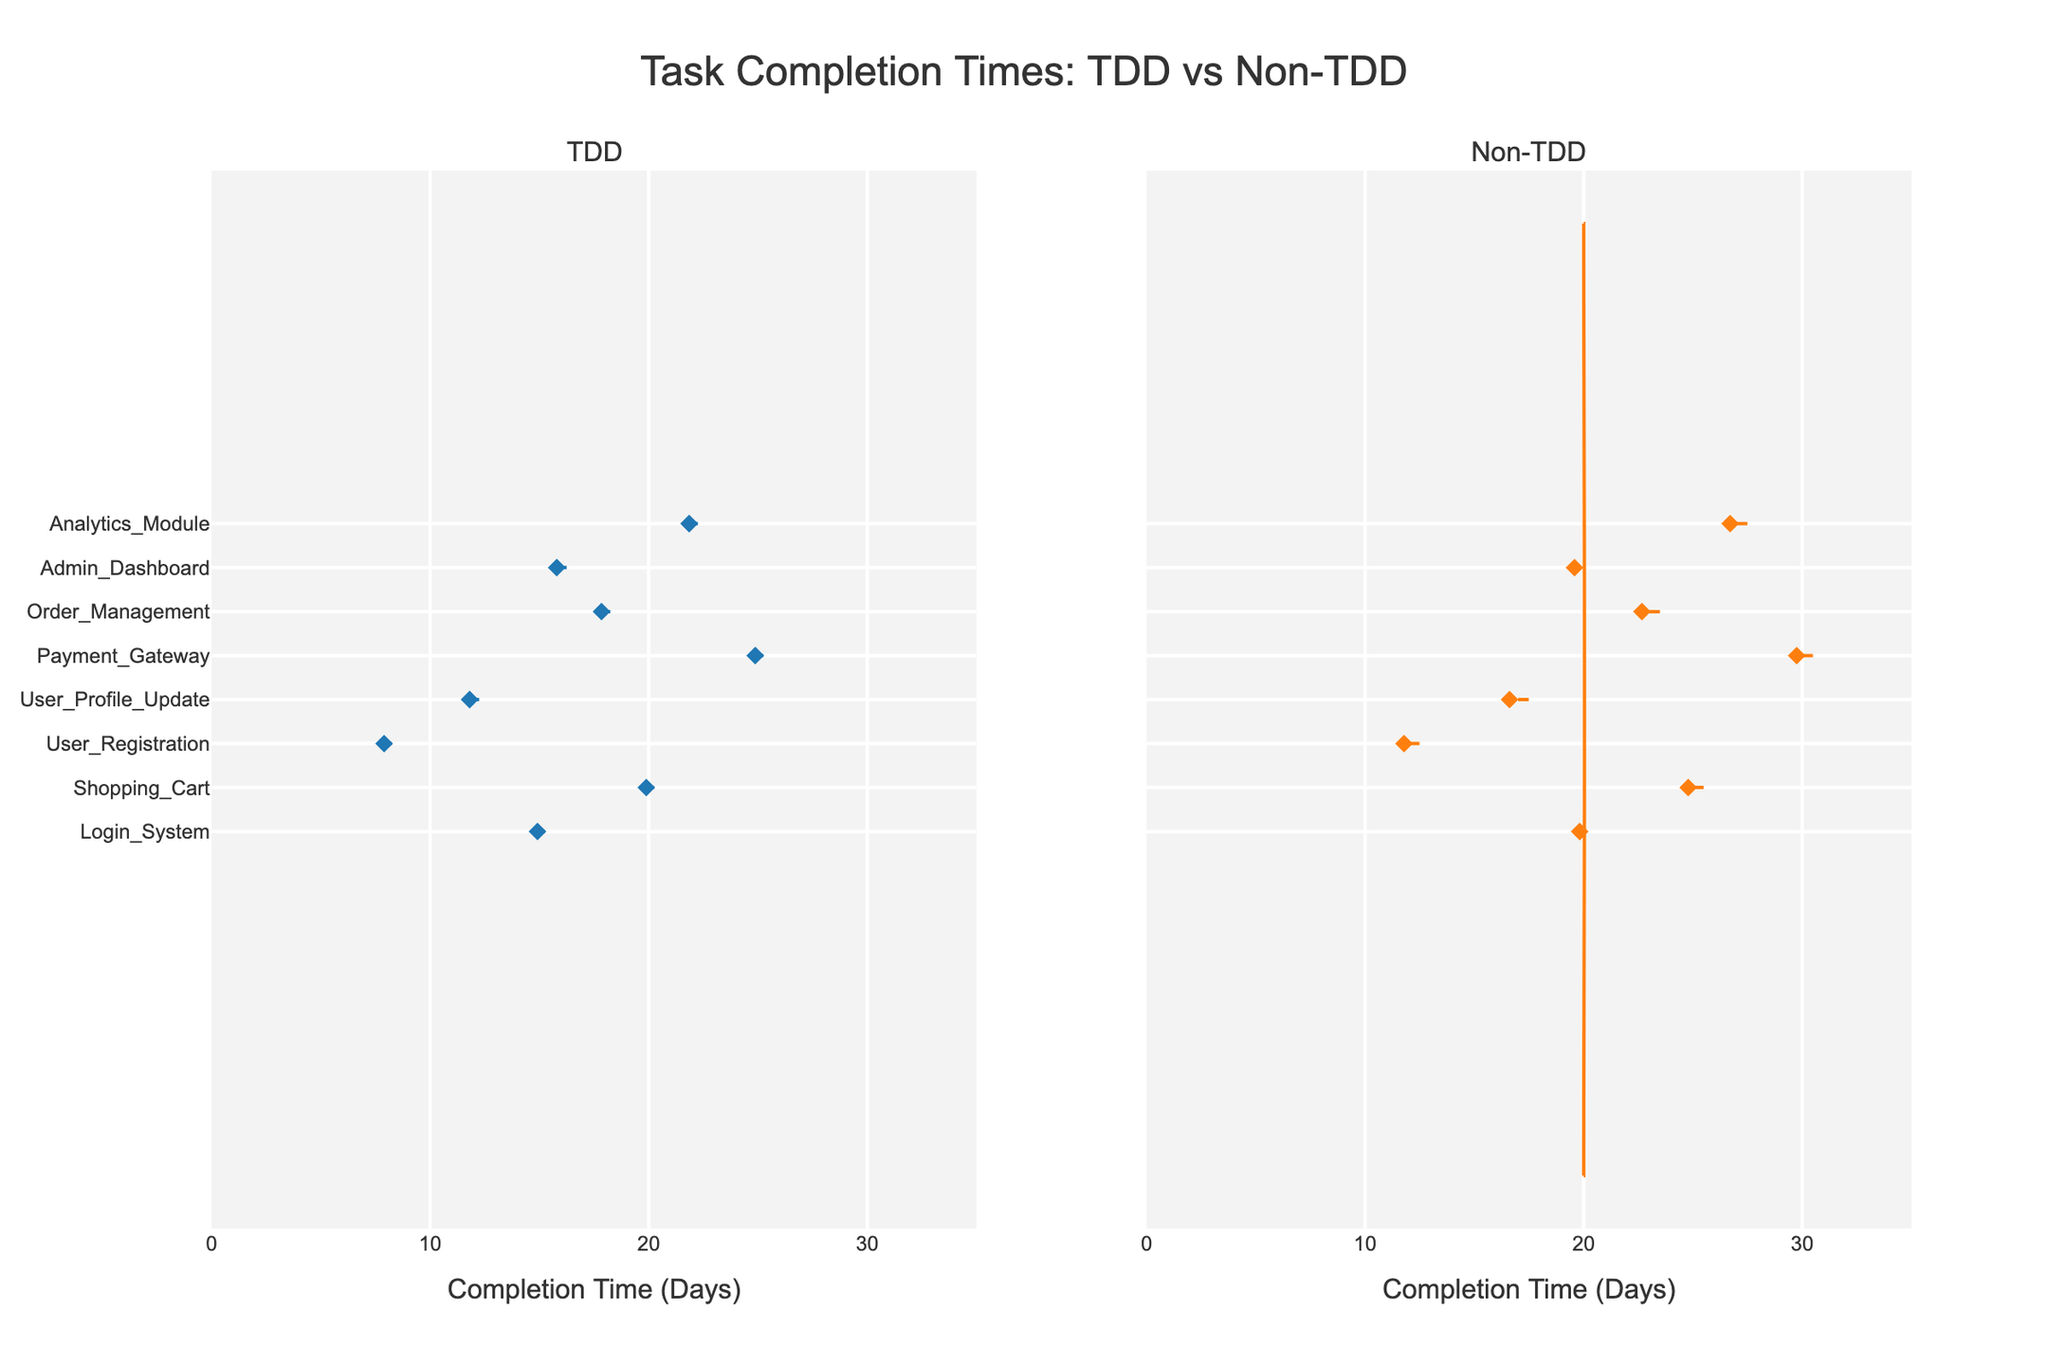What's the title of the plot? The title of the plot is centrally aligned at the top and is displayed in a larger font size. It reads "Task Completion Times: TDD vs Non-TDD".
Answer: Task Completion Times: TDD vs Non-TDD Which task has the shortest completion time under TDD? The shortest completion time under TDD can be found by identifying the lowest point on the TDD side of the plot, which corresponds to the User_Registration task with a completion time of 8 days.
Answer: User_Registration What's the range of completion times for Non-TDD? To find the range, we look at the minimum and maximum values on the Non-TDD side: the smallest value is 12 (User_Registration) and the largest value is 30 (Payment_Gateway). Subtracting the minimum from the maximum gives us 30 - 12.
Answer: 18 days How many tasks have a completion time greater than 20 days under Non-TDD? We need to count the number of tasks where the completion times are greater than 20 on the Non-TDD side: Shopping_Cart, Payment_Gateway, Order_Management, and Analytics_Module, totaling 4 tasks.
Answer: 4 tasks Which development methodology generally results in lower completion times? By comparing the overall violin plots, TDD shows lower values distributed more frequently at the lower end than Non-TDD. Specifically, the median and distribution of values for TDD shift towards lower completion times compared to Non-TDD.
Answer: TDD Compare the task completion times for the Payment_Gateway task in both methodologies. The Payment_Gateway task completion times can be read directly from the plot: TDD has a completion time of 25 days, while Non-TDD has a completion time of 30 days.
Answer: TDD: 25 days, Non-TDD: 30 days What is the median completion time for TDD? The median can be visually estimated by looking for the middle value in the distribution of TDD completion times. Observing the plot, the median falls around the 15-20 day range. More specifically, it's closer to 16.5 days since the distribution is slightly skewed.
Answer: ~16.5 days Which methodology has a more varied distribution of completion times? We can compare the spread and shape of the violin plots for both TDD and Non-TDD. The Non-TDD plot shows a wider spread of values, indicating a more varied distribution of completion times.
Answer: Non-TDD 